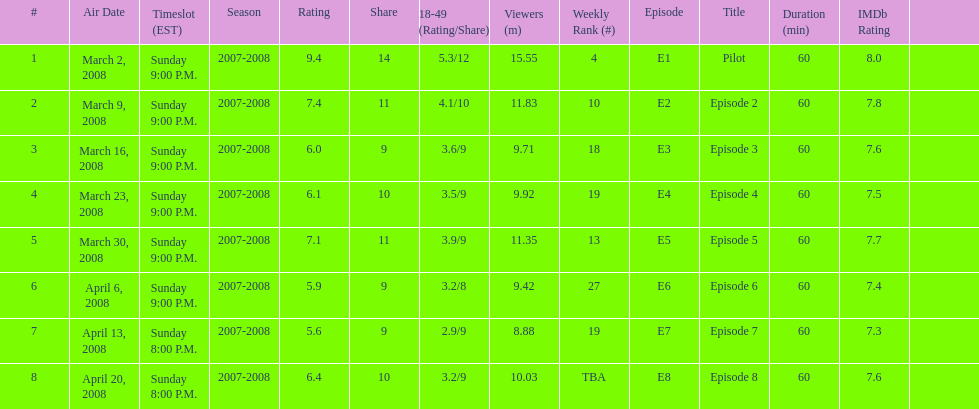How many shows had at least 10 million viewers? 4. 